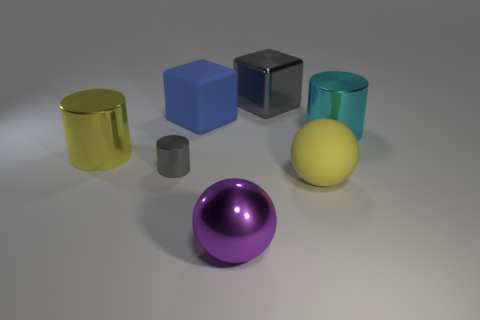There is a big ball that is made of the same material as the small cylinder; what is its color?
Your answer should be compact. Purple. Is the number of blue matte cylinders greater than the number of big metallic spheres?
Ensure brevity in your answer.  No. What size is the cylinder that is on the right side of the yellow cylinder and behind the gray cylinder?
Provide a short and direct response. Large. Are there an equal number of large blue rubber things that are on the right side of the large blue rubber object and big cyan matte cylinders?
Provide a short and direct response. Yes. Is the cyan thing the same size as the gray metal cylinder?
Provide a short and direct response. No. There is a large thing that is in front of the tiny cylinder and behind the purple ball; what is its color?
Offer a terse response. Yellow. What is the material of the large yellow thing that is in front of the yellow thing that is to the left of the large gray metal block?
Offer a very short reply. Rubber. The gray thing that is the same shape as the large blue rubber object is what size?
Provide a short and direct response. Large. Is the color of the big block that is on the right side of the purple shiny thing the same as the small metal cylinder?
Give a very brief answer. Yes. Is the number of cyan things less than the number of yellow objects?
Keep it short and to the point. Yes. 